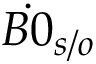Convert formula to latex. <formula><loc_0><loc_0><loc_500><loc_500>\dot { B 0 } _ { s / o }</formula> 